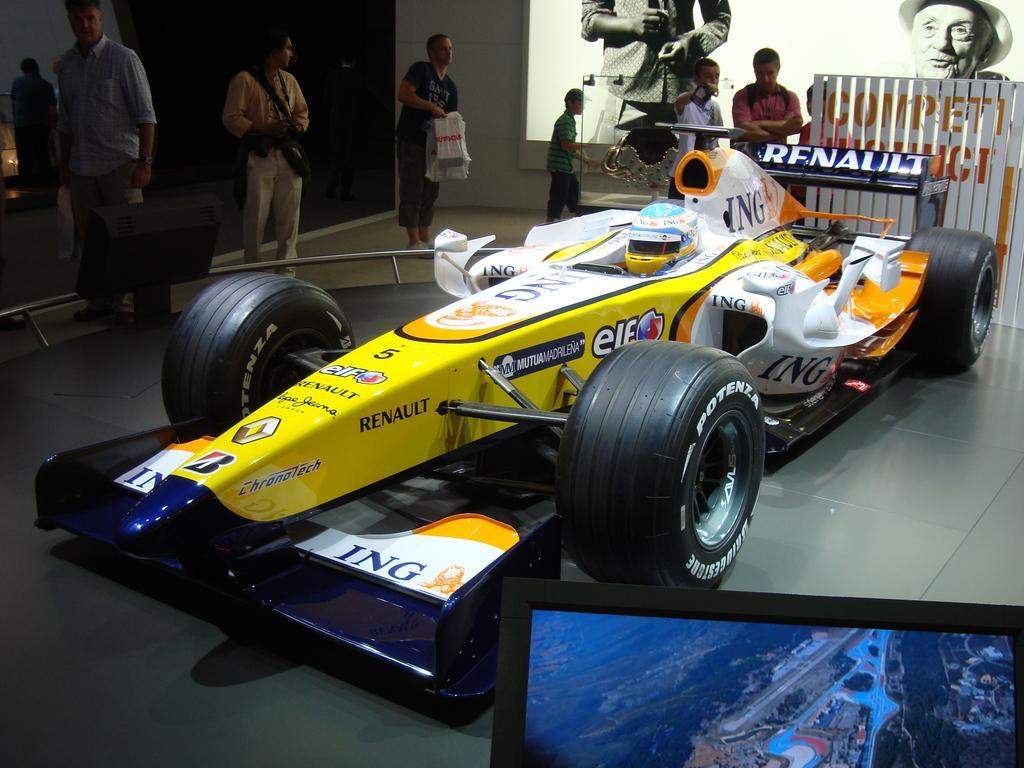Please provide a concise description of this image. In this image we can see a person wearing a helmet is sitting in a vehicle placed on the ground. On the left side of the image we can see some poles and group of people standing on the floor. One person is holding covers within his hand. In the background, we can see an object placed inside a container and we can also see some screens. 